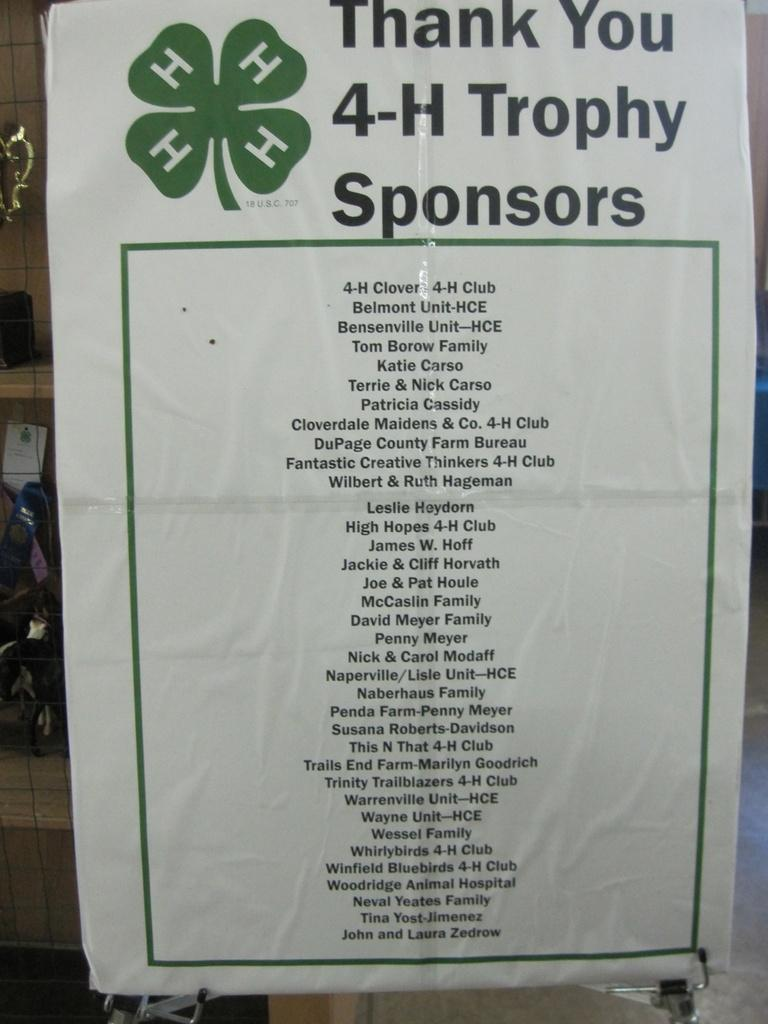<image>
Offer a succinct explanation of the picture presented. A poster thanking a list of trophy sponsors. 